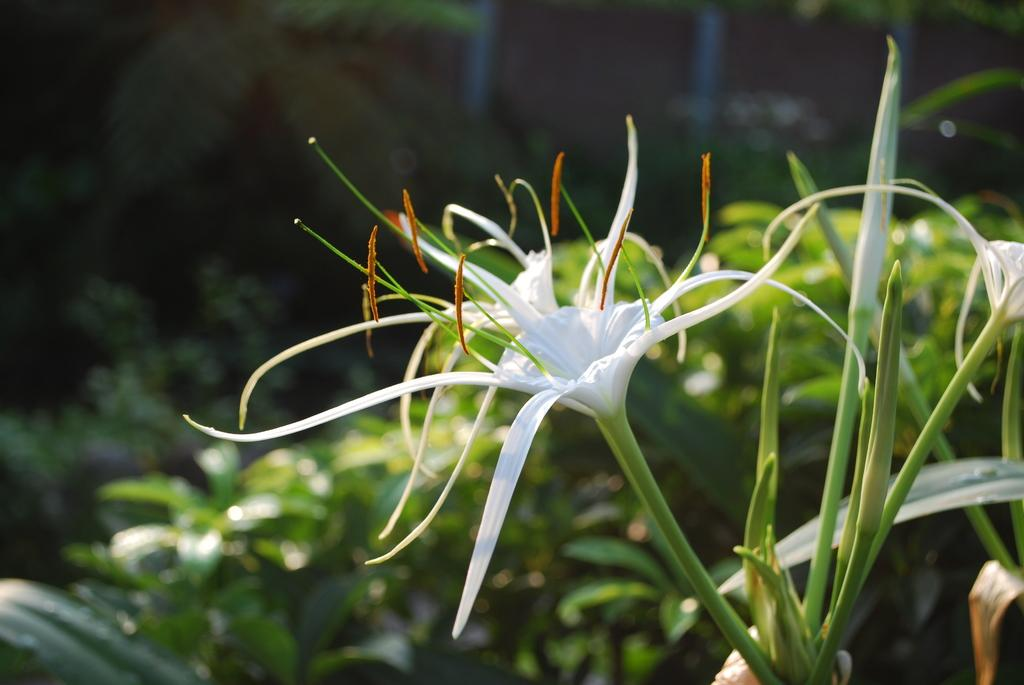What type of flowers are in the image? There are lily flowers in the image. Are there any unopened flowers in the image? Yes, there are lily buds in the image. What else can be seen in the background of the image? There are leaves in the background of the image. How would you describe the background of the image? The background is blurry. What type of skin can be seen on the chicken in the image? There is no chicken present in the image; it features lily flowers and buds. How is the honey being used in the image? There is no honey present in the image. 